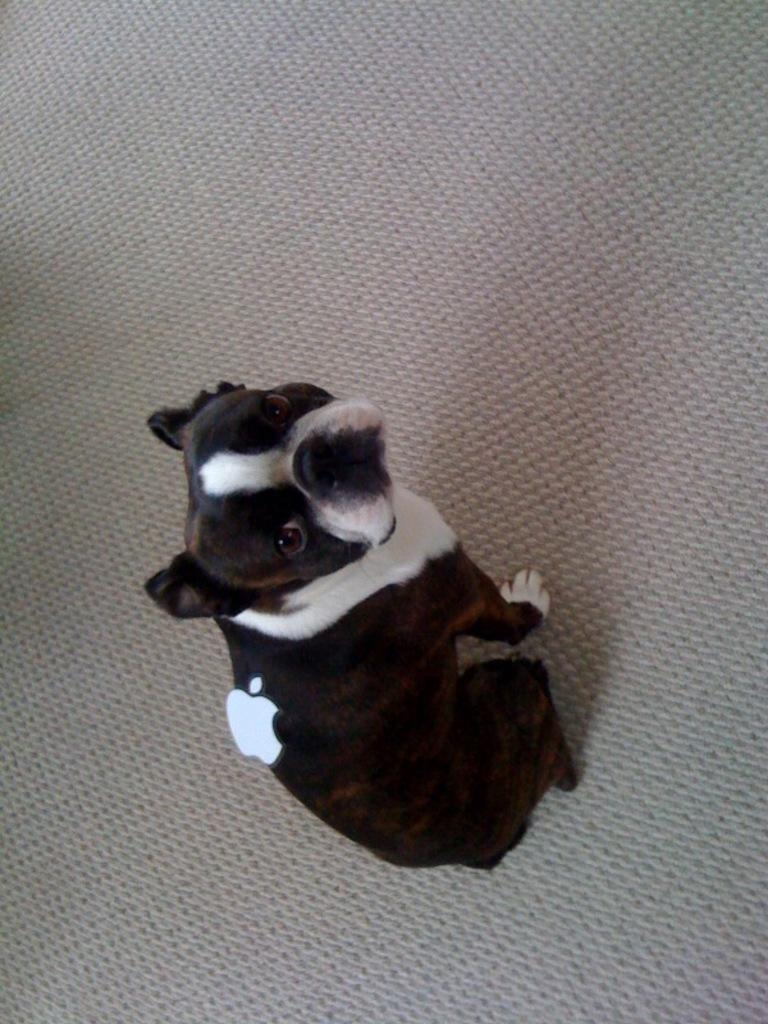Can you describe this image briefly? In this image, we can see a small black and white color puppy. 